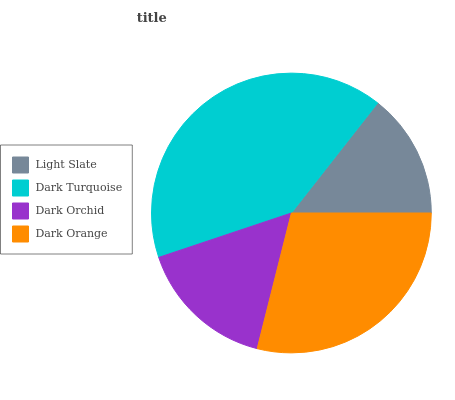Is Light Slate the minimum?
Answer yes or no. Yes. Is Dark Turquoise the maximum?
Answer yes or no. Yes. Is Dark Orchid the minimum?
Answer yes or no. No. Is Dark Orchid the maximum?
Answer yes or no. No. Is Dark Turquoise greater than Dark Orchid?
Answer yes or no. Yes. Is Dark Orchid less than Dark Turquoise?
Answer yes or no. Yes. Is Dark Orchid greater than Dark Turquoise?
Answer yes or no. No. Is Dark Turquoise less than Dark Orchid?
Answer yes or no. No. Is Dark Orange the high median?
Answer yes or no. Yes. Is Dark Orchid the low median?
Answer yes or no. Yes. Is Dark Orchid the high median?
Answer yes or no. No. Is Dark Turquoise the low median?
Answer yes or no. No. 